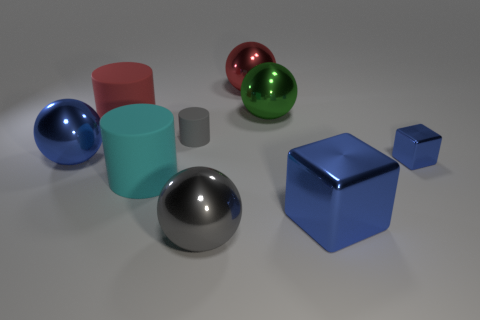Add 1 large red rubber objects. How many objects exist? 10 Subtract all balls. How many objects are left? 5 Add 7 red rubber cylinders. How many red rubber cylinders are left? 8 Add 4 small brown objects. How many small brown objects exist? 4 Subtract 1 red spheres. How many objects are left? 8 Subtract all small blue metal cylinders. Subtract all tiny shiny blocks. How many objects are left? 8 